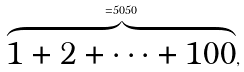Convert formula to latex. <formula><loc_0><loc_0><loc_500><loc_500>\overbrace { 1 + 2 + \cdots + 1 0 0 } ^ { = 5 0 5 0 } ,</formula> 